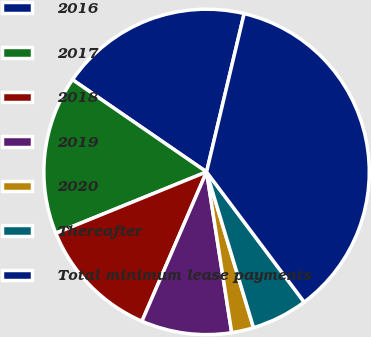Convert chart. <chart><loc_0><loc_0><loc_500><loc_500><pie_chart><fcel>2016<fcel>2017<fcel>2018<fcel>2019<fcel>2020<fcel>Thereafter<fcel>Total minimum lease payments<nl><fcel>19.12%<fcel>15.74%<fcel>12.35%<fcel>8.97%<fcel>2.19%<fcel>5.58%<fcel>36.05%<nl></chart> 